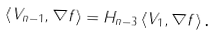<formula> <loc_0><loc_0><loc_500><loc_500>\left \langle V _ { n - 1 } , \nabla f \right \rangle = H _ { n - 3 } \left \langle V _ { 1 } , \nabla f \right \rangle \text {.}</formula> 